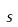<formula> <loc_0><loc_0><loc_500><loc_500>s</formula> 